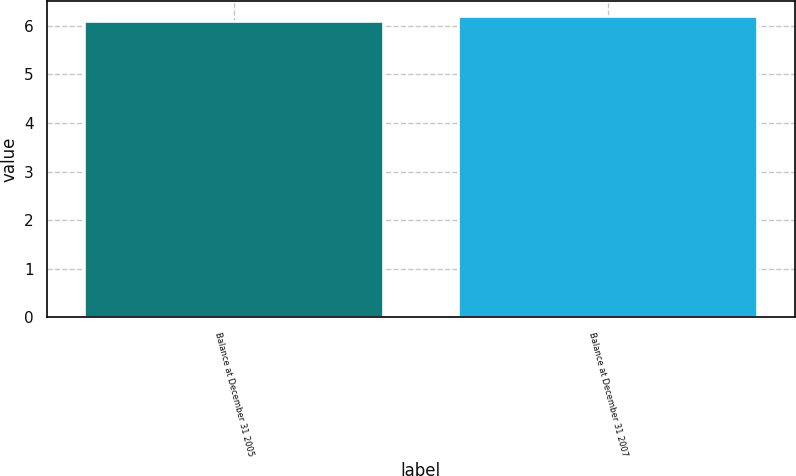Convert chart to OTSL. <chart><loc_0><loc_0><loc_500><loc_500><bar_chart><fcel>Balance at December 31 2005<fcel>Balance at December 31 2007<nl><fcel>6.1<fcel>6.2<nl></chart> 